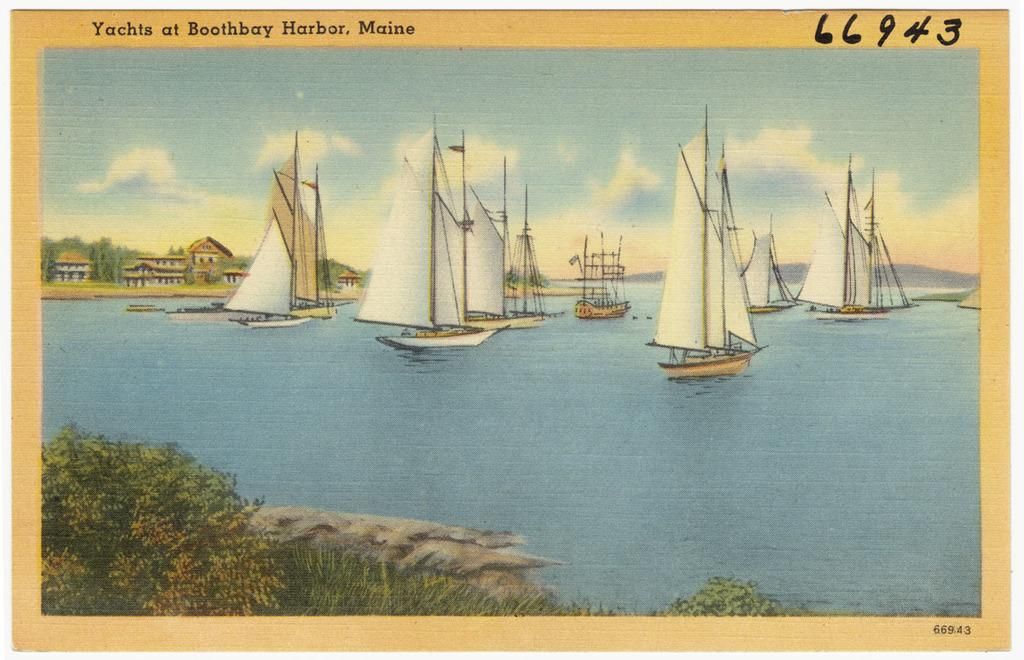<image>
Render a clear and concise summary of the photo. A postcard of yachts in Maine is labeled 66943. 